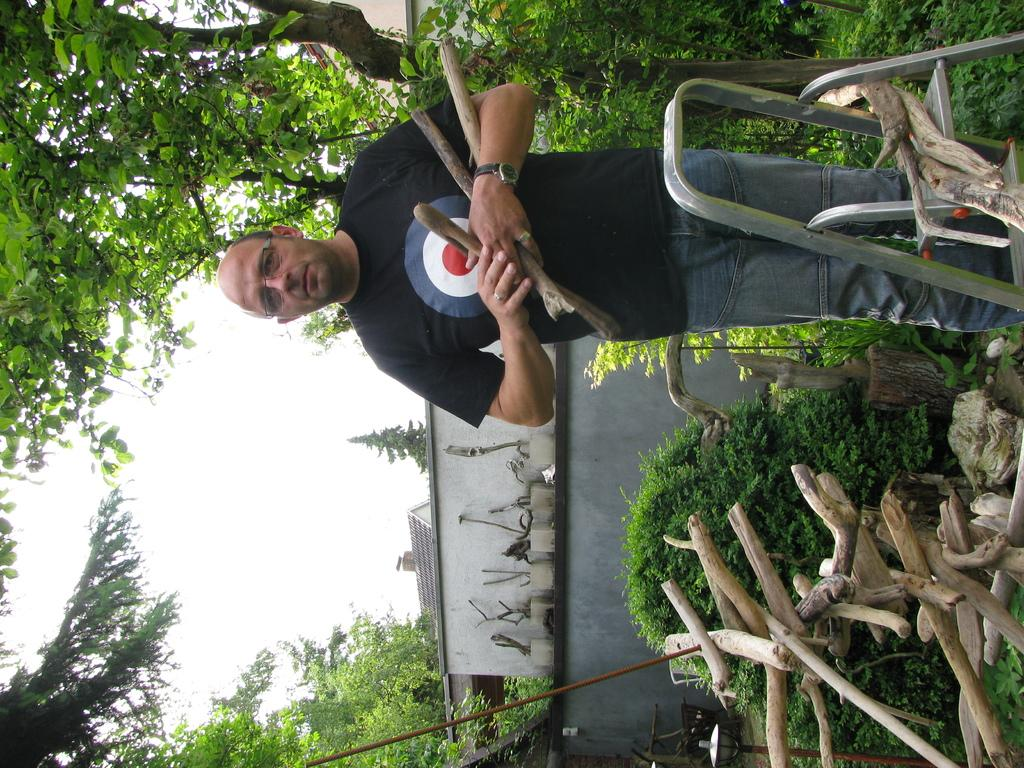Who is present in the image? There is a man in the image. What is the man holding in his hands? The man is holding wooden sticks in his hands. What can be seen in the background of the image? There are trees around the area of the image. How many giants can be seen in the image? There are no giants present in the image. What type of stamp is the man using in the image? There is no stamp present in the image; the man is holding wooden sticks. 